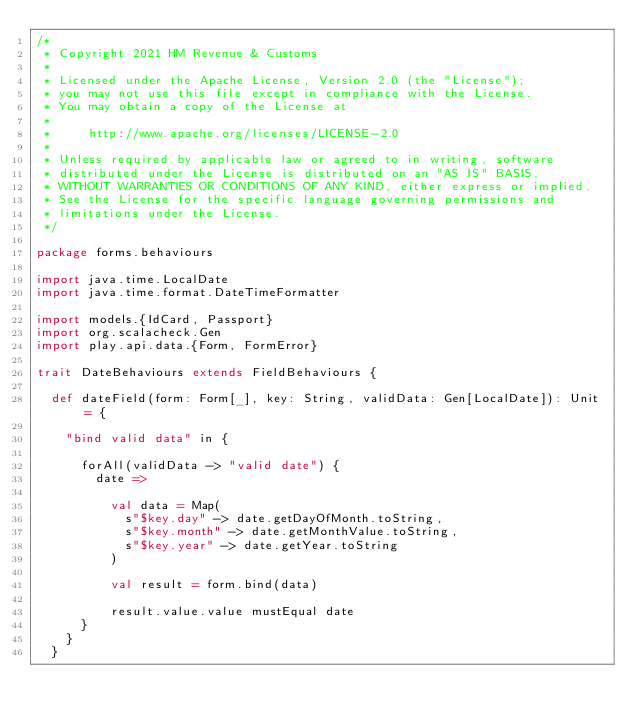<code> <loc_0><loc_0><loc_500><loc_500><_Scala_>/*
 * Copyright 2021 HM Revenue & Customs
 *
 * Licensed under the Apache License, Version 2.0 (the "License");
 * you may not use this file except in compliance with the License.
 * You may obtain a copy of the License at
 *
 *     http://www.apache.org/licenses/LICENSE-2.0
 *
 * Unless required by applicable law or agreed to in writing, software
 * distributed under the License is distributed on an "AS IS" BASIS,
 * WITHOUT WARRANTIES OR CONDITIONS OF ANY KIND, either express or implied.
 * See the License for the specific language governing permissions and
 * limitations under the License.
 */

package forms.behaviours

import java.time.LocalDate
import java.time.format.DateTimeFormatter

import models.{IdCard, Passport}
import org.scalacheck.Gen
import play.api.data.{Form, FormError}

trait DateBehaviours extends FieldBehaviours {

  def dateField(form: Form[_], key: String, validData: Gen[LocalDate]): Unit = {

    "bind valid data" in {

      forAll(validData -> "valid date") {
        date =>

          val data = Map(
            s"$key.day" -> date.getDayOfMonth.toString,
            s"$key.month" -> date.getMonthValue.toString,
            s"$key.year" -> date.getYear.toString
          )

          val result = form.bind(data)

          result.value.value mustEqual date
      }
    }
  }
</code> 